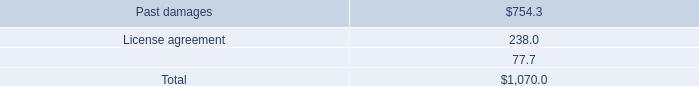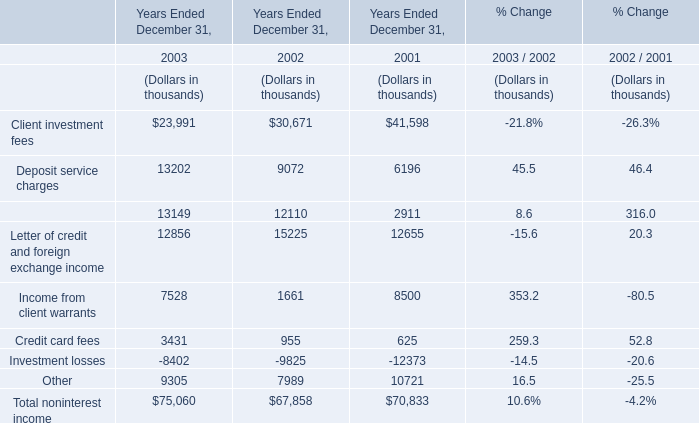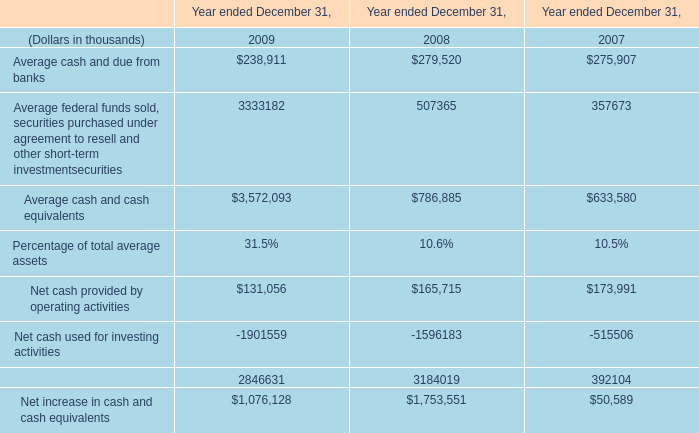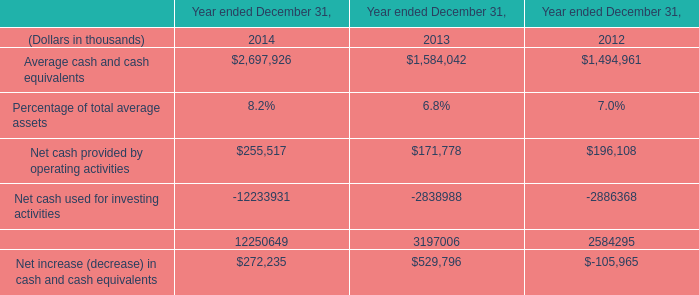What's the average of the Average cash and cash equivalents in 2014 and Average cash and due from banks in 2009 ? 
Computations: ((2697926 + 238911) / 2)
Answer: 1468418.5. 